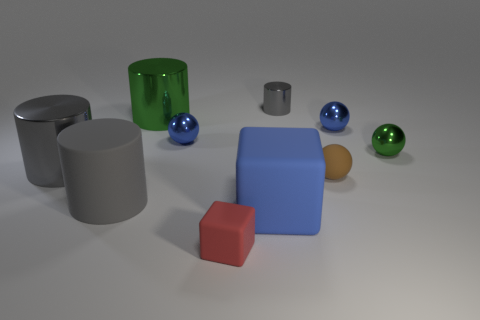There is a object that is both to the left of the small red object and in front of the brown rubber thing; what is its size?
Your answer should be very brief. Large. Is the color of the small metallic sphere left of the tiny gray cylinder the same as the matte cube on the right side of the tiny red block?
Your answer should be compact. Yes. Are there fewer tiny red things than big shiny cylinders?
Offer a terse response. Yes. There is a gray thing that is behind the green sphere; does it have the same shape as the large green thing?
Provide a succinct answer. Yes. Are any purple matte cylinders visible?
Keep it short and to the point. No. There is a large cylinder that is behind the small blue sphere that is right of the small rubber thing that is in front of the tiny brown rubber sphere; what color is it?
Ensure brevity in your answer.  Green. Is the number of tiny red cubes on the right side of the tiny green ball the same as the number of brown spheres that are left of the small shiny cylinder?
Offer a terse response. Yes. What is the shape of the green thing that is the same size as the brown matte ball?
Make the answer very short. Sphere. Is there a small metallic cylinder of the same color as the tiny rubber sphere?
Keep it short and to the point. No. There is a rubber object in front of the blue rubber thing; what shape is it?
Ensure brevity in your answer.  Cube. 